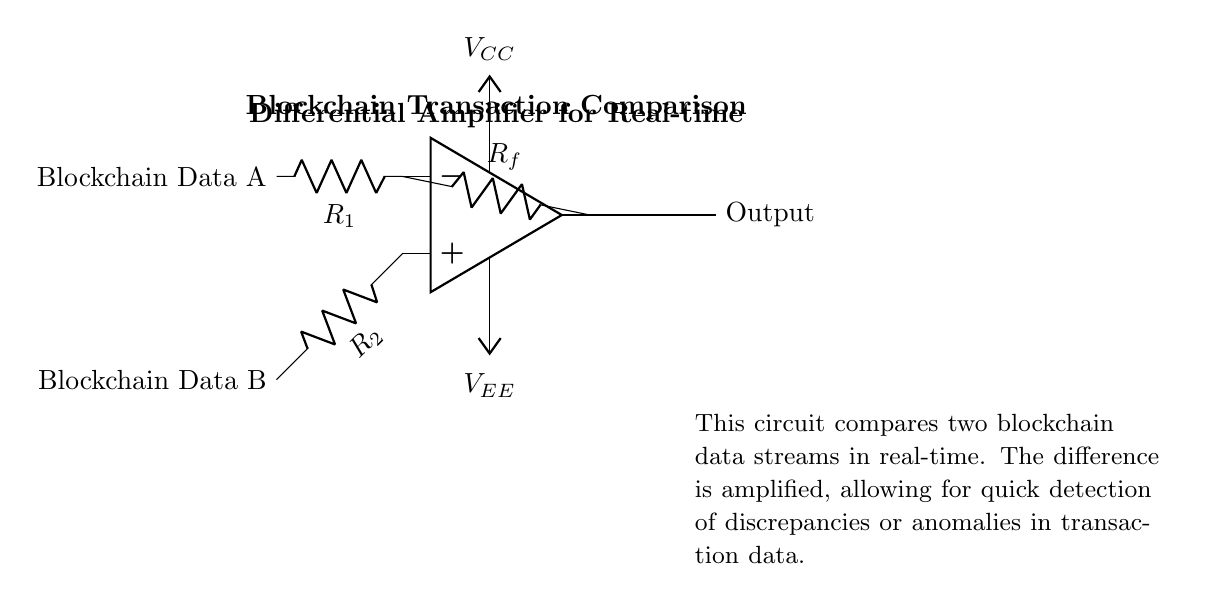What are the two types of blockchain data being compared? The circuit has two inputs labeled as Blockchain Data A and Blockchain Data B, which indicates the different data streams being compared in real-time.
Answer: Blockchain Data A, Blockchain Data B What is the function of the feedback resistor? The feedback resistor connects the output to the inverting input terminal, setting the gain of the differential amplifier and enabling it to control the output signal based on the input difference.
Answer: Feedback resistor gain control What is the amplification type used in this circuit? The circuit uses a differential amplifier configuration, which amplifies the difference between two input voltages.
Answer: Differential amplification What are the power supply voltages in this circuit? The circuit is powered by two voltage levels indicated as VCC (positive supply) and VEE (negative supply), which are essential for the operation of the operational amplifier.
Answer: VCC, VEE What is the role of resistors R1 and R2? Resistors R1 and R2 are used to set the sensitivity and scale of the inputs from the two data streams, allowing for an effective comparison of the signal voltages.
Answer: Sensitivity and scaling What does the output indicate in this circuit? The output represents the amplified difference between the two input blockchain data signals, facilitating the quick detection of discrepancies or anomalies in transaction data.
Answer: Amplified difference output 